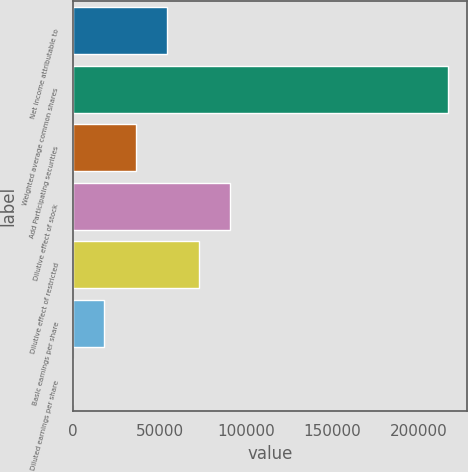Convert chart to OTSL. <chart><loc_0><loc_0><loc_500><loc_500><bar_chart><fcel>Net income attributable to<fcel>Weighted average common shares<fcel>Add Participating securities<fcel>Dilutive effect of stock<fcel>Dilutive effect of restricted<fcel>Basic earnings per share<fcel>Diluted earnings per share<nl><fcel>54522.4<fcel>217201<fcel>36348.9<fcel>90869.4<fcel>72695.9<fcel>18175.4<fcel>1.87<nl></chart> 